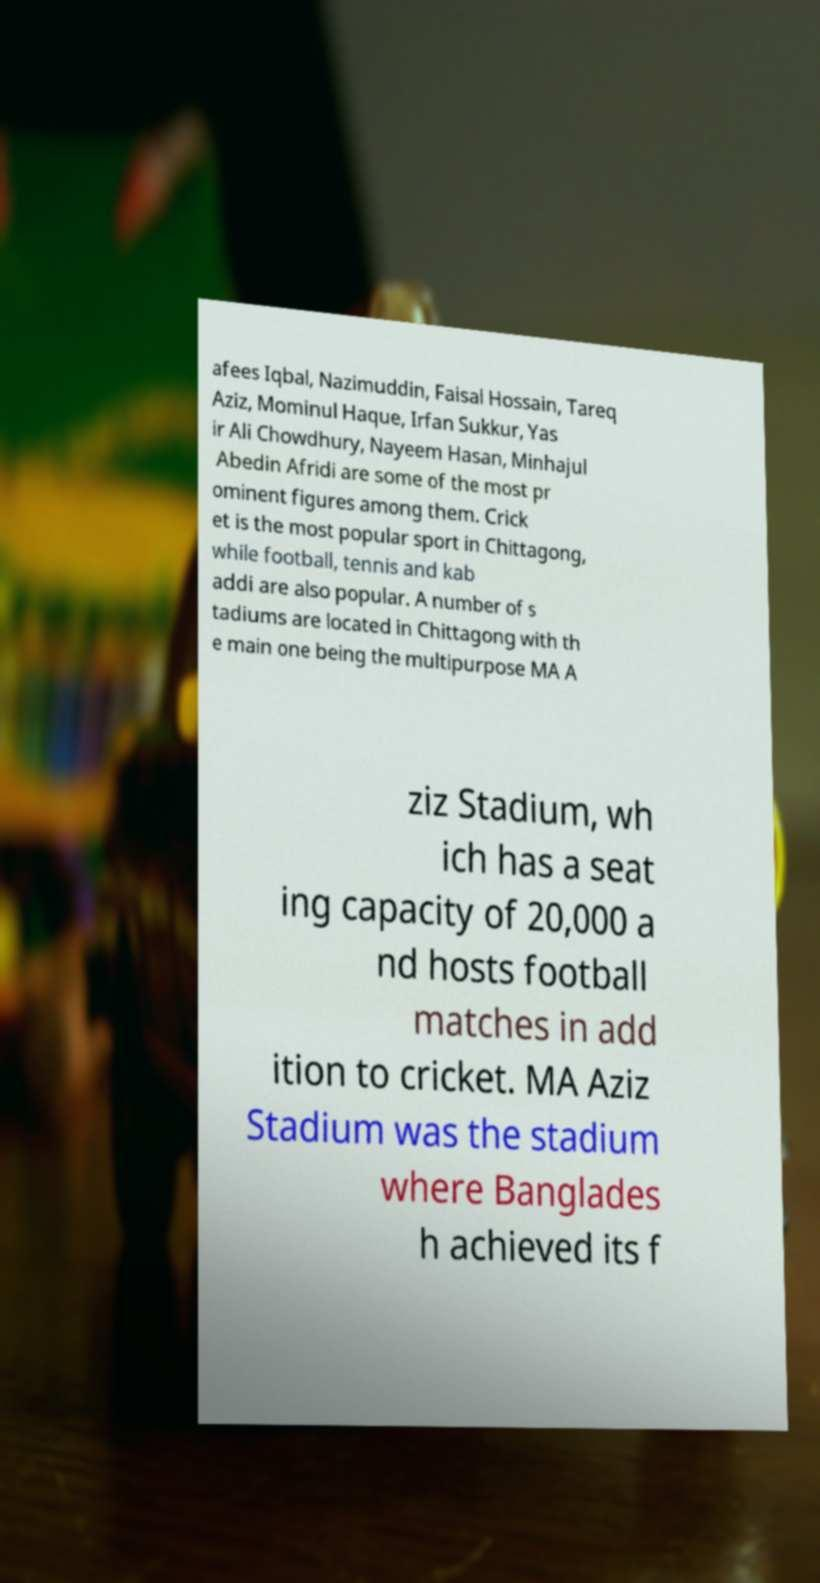Could you assist in decoding the text presented in this image and type it out clearly? afees Iqbal, Nazimuddin, Faisal Hossain, Tareq Aziz, Mominul Haque, Irfan Sukkur, Yas ir Ali Chowdhury, Nayeem Hasan, Minhajul Abedin Afridi are some of the most pr ominent figures among them. Crick et is the most popular sport in Chittagong, while football, tennis and kab addi are also popular. A number of s tadiums are located in Chittagong with th e main one being the multipurpose MA A ziz Stadium, wh ich has a seat ing capacity of 20,000 a nd hosts football matches in add ition to cricket. MA Aziz Stadium was the stadium where Banglades h achieved its f 